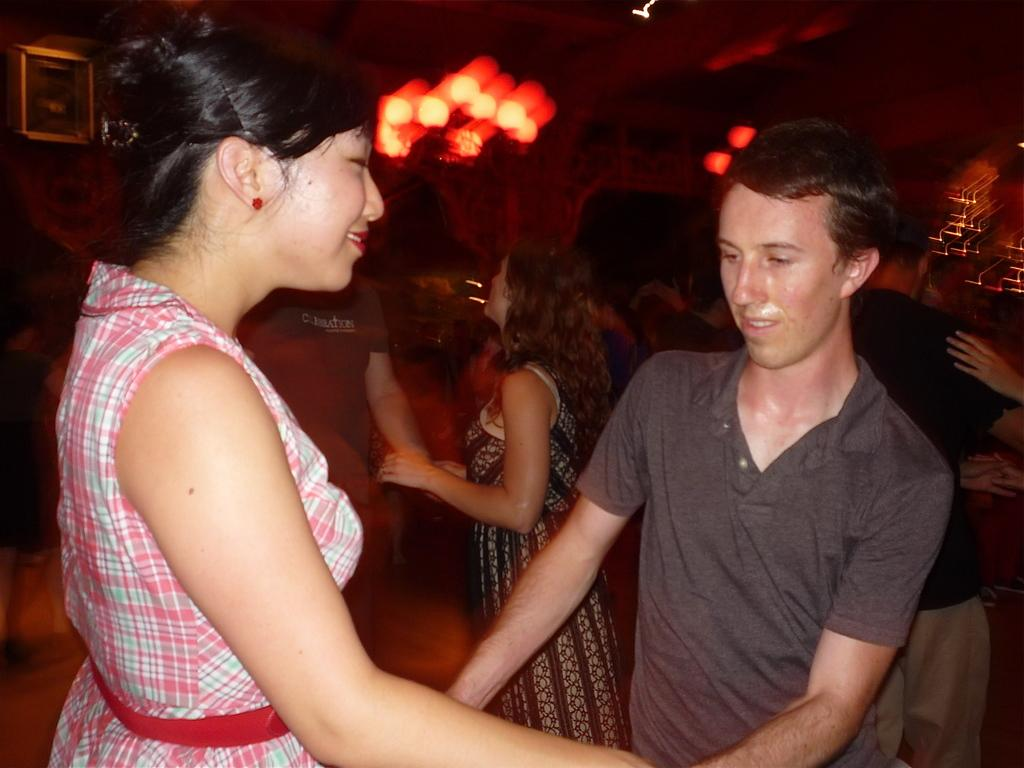What are the people in the image doing? The people in the image are dancing. Can you describe the background of the image? The background of the image is blurred. What type of building can be seen in the background of the image? There is no building visible in the image; the background is blurred. How many elbows can be seen on the dancers in the image? It is impossible to count the number of elbows on the dancers in the image, as the focus is on their dancing and not specific body parts. 